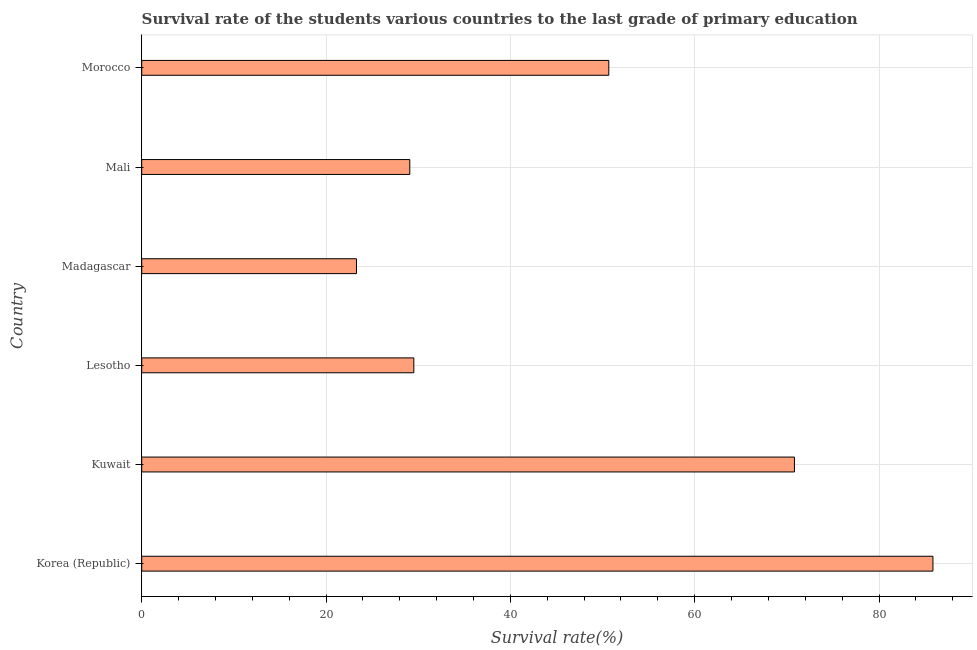Does the graph contain any zero values?
Your answer should be compact. No. What is the title of the graph?
Give a very brief answer. Survival rate of the students various countries to the last grade of primary education. What is the label or title of the X-axis?
Keep it short and to the point. Survival rate(%). What is the label or title of the Y-axis?
Provide a succinct answer. Country. What is the survival rate in primary education in Lesotho?
Keep it short and to the point. 29.53. Across all countries, what is the maximum survival rate in primary education?
Provide a succinct answer. 85.85. Across all countries, what is the minimum survival rate in primary education?
Offer a very short reply. 23.3. In which country was the survival rate in primary education minimum?
Offer a very short reply. Madagascar. What is the sum of the survival rate in primary education?
Keep it short and to the point. 289.26. What is the difference between the survival rate in primary education in Korea (Republic) and Kuwait?
Offer a very short reply. 15.03. What is the average survival rate in primary education per country?
Make the answer very short. 48.21. What is the median survival rate in primary education?
Offer a very short reply. 40.1. In how many countries, is the survival rate in primary education greater than 4 %?
Make the answer very short. 6. What is the ratio of the survival rate in primary education in Korea (Republic) to that in Madagascar?
Your answer should be compact. 3.68. Is the difference between the survival rate in primary education in Korea (Republic) and Mali greater than the difference between any two countries?
Your response must be concise. No. What is the difference between the highest and the second highest survival rate in primary education?
Your answer should be compact. 15.03. What is the difference between the highest and the lowest survival rate in primary education?
Your response must be concise. 62.55. In how many countries, is the survival rate in primary education greater than the average survival rate in primary education taken over all countries?
Make the answer very short. 3. How many bars are there?
Ensure brevity in your answer.  6. What is the difference between two consecutive major ticks on the X-axis?
Provide a succinct answer. 20. What is the Survival rate(%) in Korea (Republic)?
Provide a succinct answer. 85.85. What is the Survival rate(%) of Kuwait?
Make the answer very short. 70.82. What is the Survival rate(%) of Lesotho?
Give a very brief answer. 29.53. What is the Survival rate(%) in Madagascar?
Your answer should be very brief. 23.3. What is the Survival rate(%) in Mali?
Your response must be concise. 29.09. What is the Survival rate(%) of Morocco?
Ensure brevity in your answer.  50.68. What is the difference between the Survival rate(%) in Korea (Republic) and Kuwait?
Ensure brevity in your answer.  15.03. What is the difference between the Survival rate(%) in Korea (Republic) and Lesotho?
Your answer should be compact. 56.32. What is the difference between the Survival rate(%) in Korea (Republic) and Madagascar?
Your answer should be compact. 62.55. What is the difference between the Survival rate(%) in Korea (Republic) and Mali?
Your answer should be compact. 56.76. What is the difference between the Survival rate(%) in Korea (Republic) and Morocco?
Keep it short and to the point. 35.17. What is the difference between the Survival rate(%) in Kuwait and Lesotho?
Your response must be concise. 41.3. What is the difference between the Survival rate(%) in Kuwait and Madagascar?
Provide a succinct answer. 47.52. What is the difference between the Survival rate(%) in Kuwait and Mali?
Your answer should be very brief. 41.74. What is the difference between the Survival rate(%) in Kuwait and Morocco?
Your answer should be very brief. 20.14. What is the difference between the Survival rate(%) in Lesotho and Madagascar?
Make the answer very short. 6.22. What is the difference between the Survival rate(%) in Lesotho and Mali?
Your answer should be compact. 0.44. What is the difference between the Survival rate(%) in Lesotho and Morocco?
Ensure brevity in your answer.  -21.15. What is the difference between the Survival rate(%) in Madagascar and Mali?
Ensure brevity in your answer.  -5.78. What is the difference between the Survival rate(%) in Madagascar and Morocco?
Give a very brief answer. -27.38. What is the difference between the Survival rate(%) in Mali and Morocco?
Your answer should be compact. -21.59. What is the ratio of the Survival rate(%) in Korea (Republic) to that in Kuwait?
Ensure brevity in your answer.  1.21. What is the ratio of the Survival rate(%) in Korea (Republic) to that in Lesotho?
Make the answer very short. 2.91. What is the ratio of the Survival rate(%) in Korea (Republic) to that in Madagascar?
Provide a succinct answer. 3.68. What is the ratio of the Survival rate(%) in Korea (Republic) to that in Mali?
Give a very brief answer. 2.95. What is the ratio of the Survival rate(%) in Korea (Republic) to that in Morocco?
Offer a very short reply. 1.69. What is the ratio of the Survival rate(%) in Kuwait to that in Lesotho?
Keep it short and to the point. 2.4. What is the ratio of the Survival rate(%) in Kuwait to that in Madagascar?
Your answer should be compact. 3.04. What is the ratio of the Survival rate(%) in Kuwait to that in Mali?
Offer a terse response. 2.44. What is the ratio of the Survival rate(%) in Kuwait to that in Morocco?
Give a very brief answer. 1.4. What is the ratio of the Survival rate(%) in Lesotho to that in Madagascar?
Your answer should be compact. 1.27. What is the ratio of the Survival rate(%) in Lesotho to that in Mali?
Offer a very short reply. 1.01. What is the ratio of the Survival rate(%) in Lesotho to that in Morocco?
Your response must be concise. 0.58. What is the ratio of the Survival rate(%) in Madagascar to that in Mali?
Keep it short and to the point. 0.8. What is the ratio of the Survival rate(%) in Madagascar to that in Morocco?
Offer a terse response. 0.46. What is the ratio of the Survival rate(%) in Mali to that in Morocco?
Make the answer very short. 0.57. 